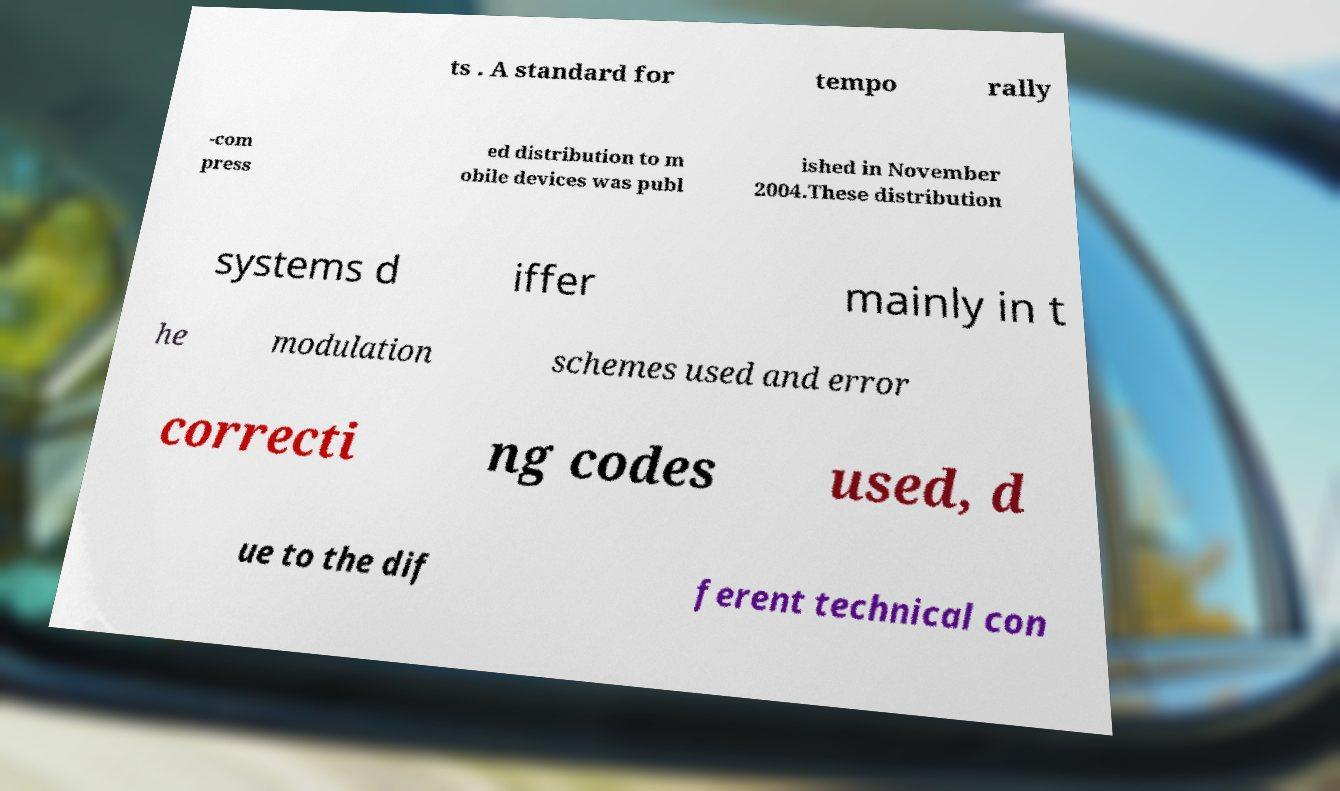Could you assist in decoding the text presented in this image and type it out clearly? ts . A standard for tempo rally -com press ed distribution to m obile devices was publ ished in November 2004.These distribution systems d iffer mainly in t he modulation schemes used and error correcti ng codes used, d ue to the dif ferent technical con 